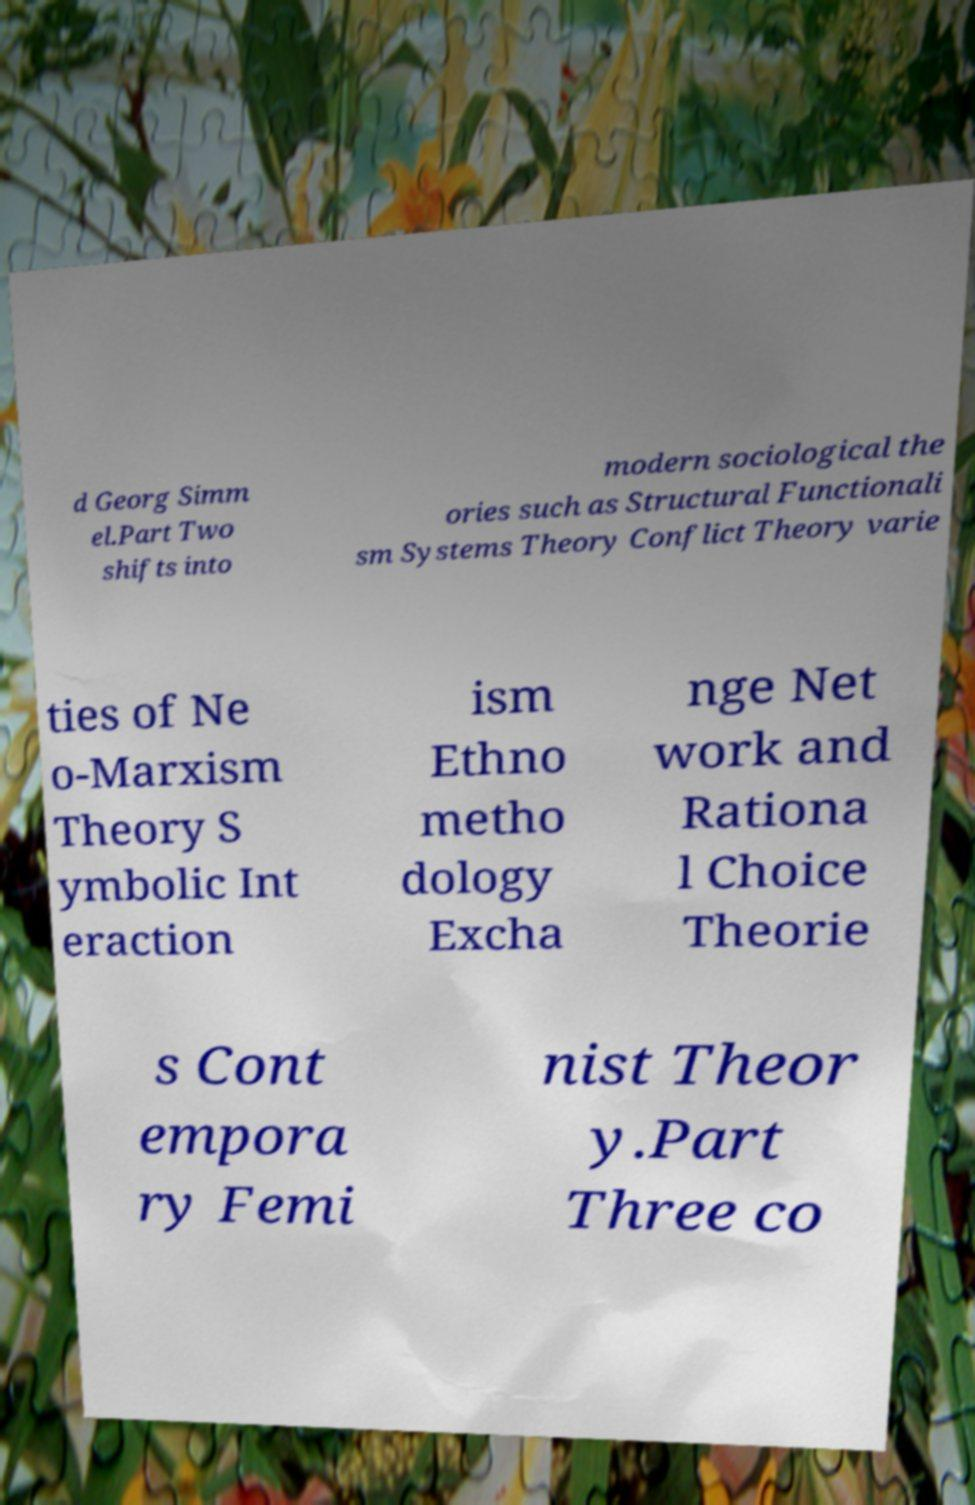Can you read and provide the text displayed in the image?This photo seems to have some interesting text. Can you extract and type it out for me? d Georg Simm el.Part Two shifts into modern sociological the ories such as Structural Functionali sm Systems Theory Conflict Theory varie ties of Ne o-Marxism Theory S ymbolic Int eraction ism Ethno metho dology Excha nge Net work and Rationa l Choice Theorie s Cont empora ry Femi nist Theor y.Part Three co 